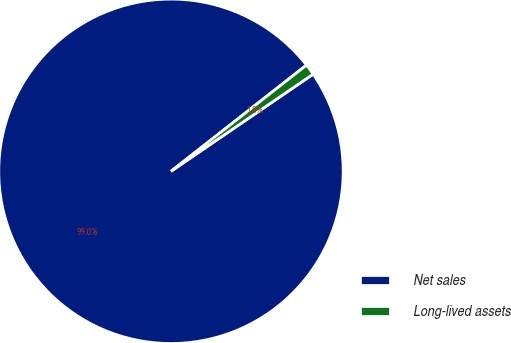<chart> <loc_0><loc_0><loc_500><loc_500><pie_chart><fcel>Net sales<fcel>Long-lived assets<nl><fcel>98.96%<fcel>1.04%<nl></chart> 